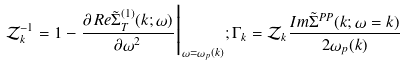Convert formula to latex. <formula><loc_0><loc_0><loc_500><loc_500>\mathcal { Z } ^ { - 1 } _ { k } = 1 - \frac { \partial \, R e \tilde { \Sigma } ^ { ( 1 ) } _ { T } ( k ; \omega ) } { \partial \omega ^ { 2 } } \Big | _ { \omega = \omega _ { p } ( k ) } ; \Gamma _ { k } = \mathcal { Z } _ { k } \frac { I m \tilde { \Sigma } ^ { P P } ( k ; \omega = k ) } { 2 \omega _ { p } ( k ) }</formula> 